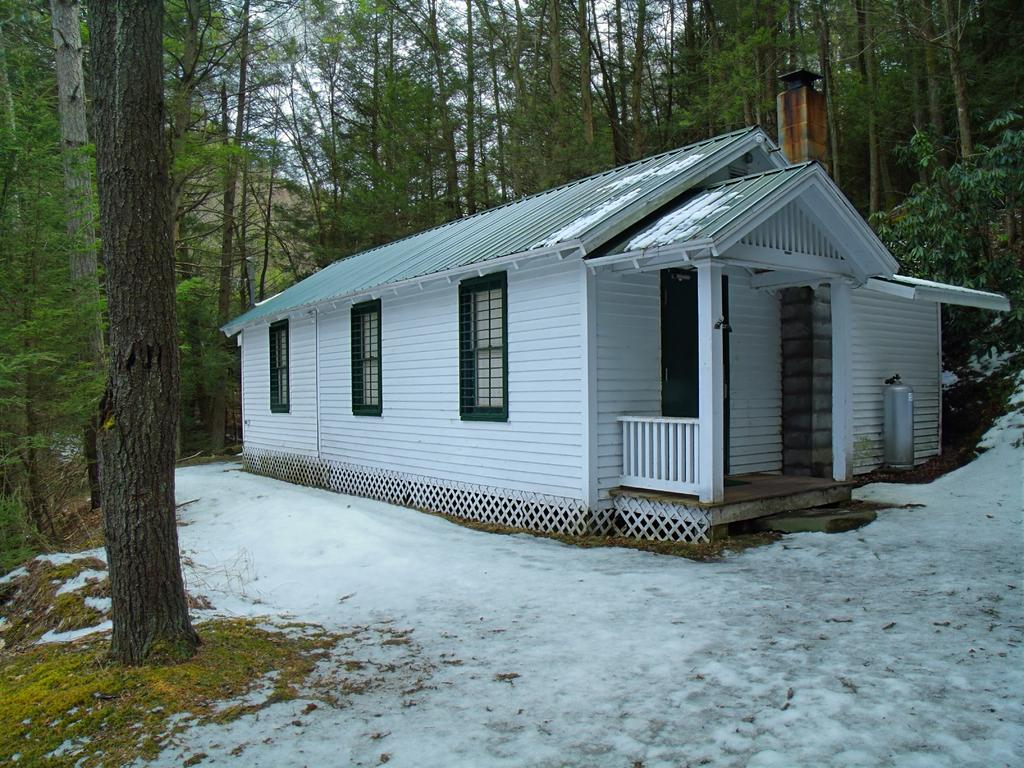What is covering the ground in the image? There is snow on the ground in the image. What can be seen in the distance in the image? There is a house and trees in the background of the image. What type of bead is being used to decorate the carriage in the image? There is no carriage or bead present in the image. How many pies are visible on the windowsill in the image? There are no pies visible in the image. 